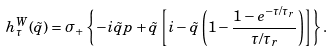<formula> <loc_0><loc_0><loc_500><loc_500>h _ { \tau } ^ { W } ( \tilde { q } ) = \sigma _ { + } \left \{ - i \tilde { q } p + \tilde { q } \left [ i - \tilde { q } \left ( 1 - \frac { 1 - e ^ { - \tau / \tau _ { r } } } { \tau / \tau _ { r } } \right ) \right ] \right \} .</formula> 